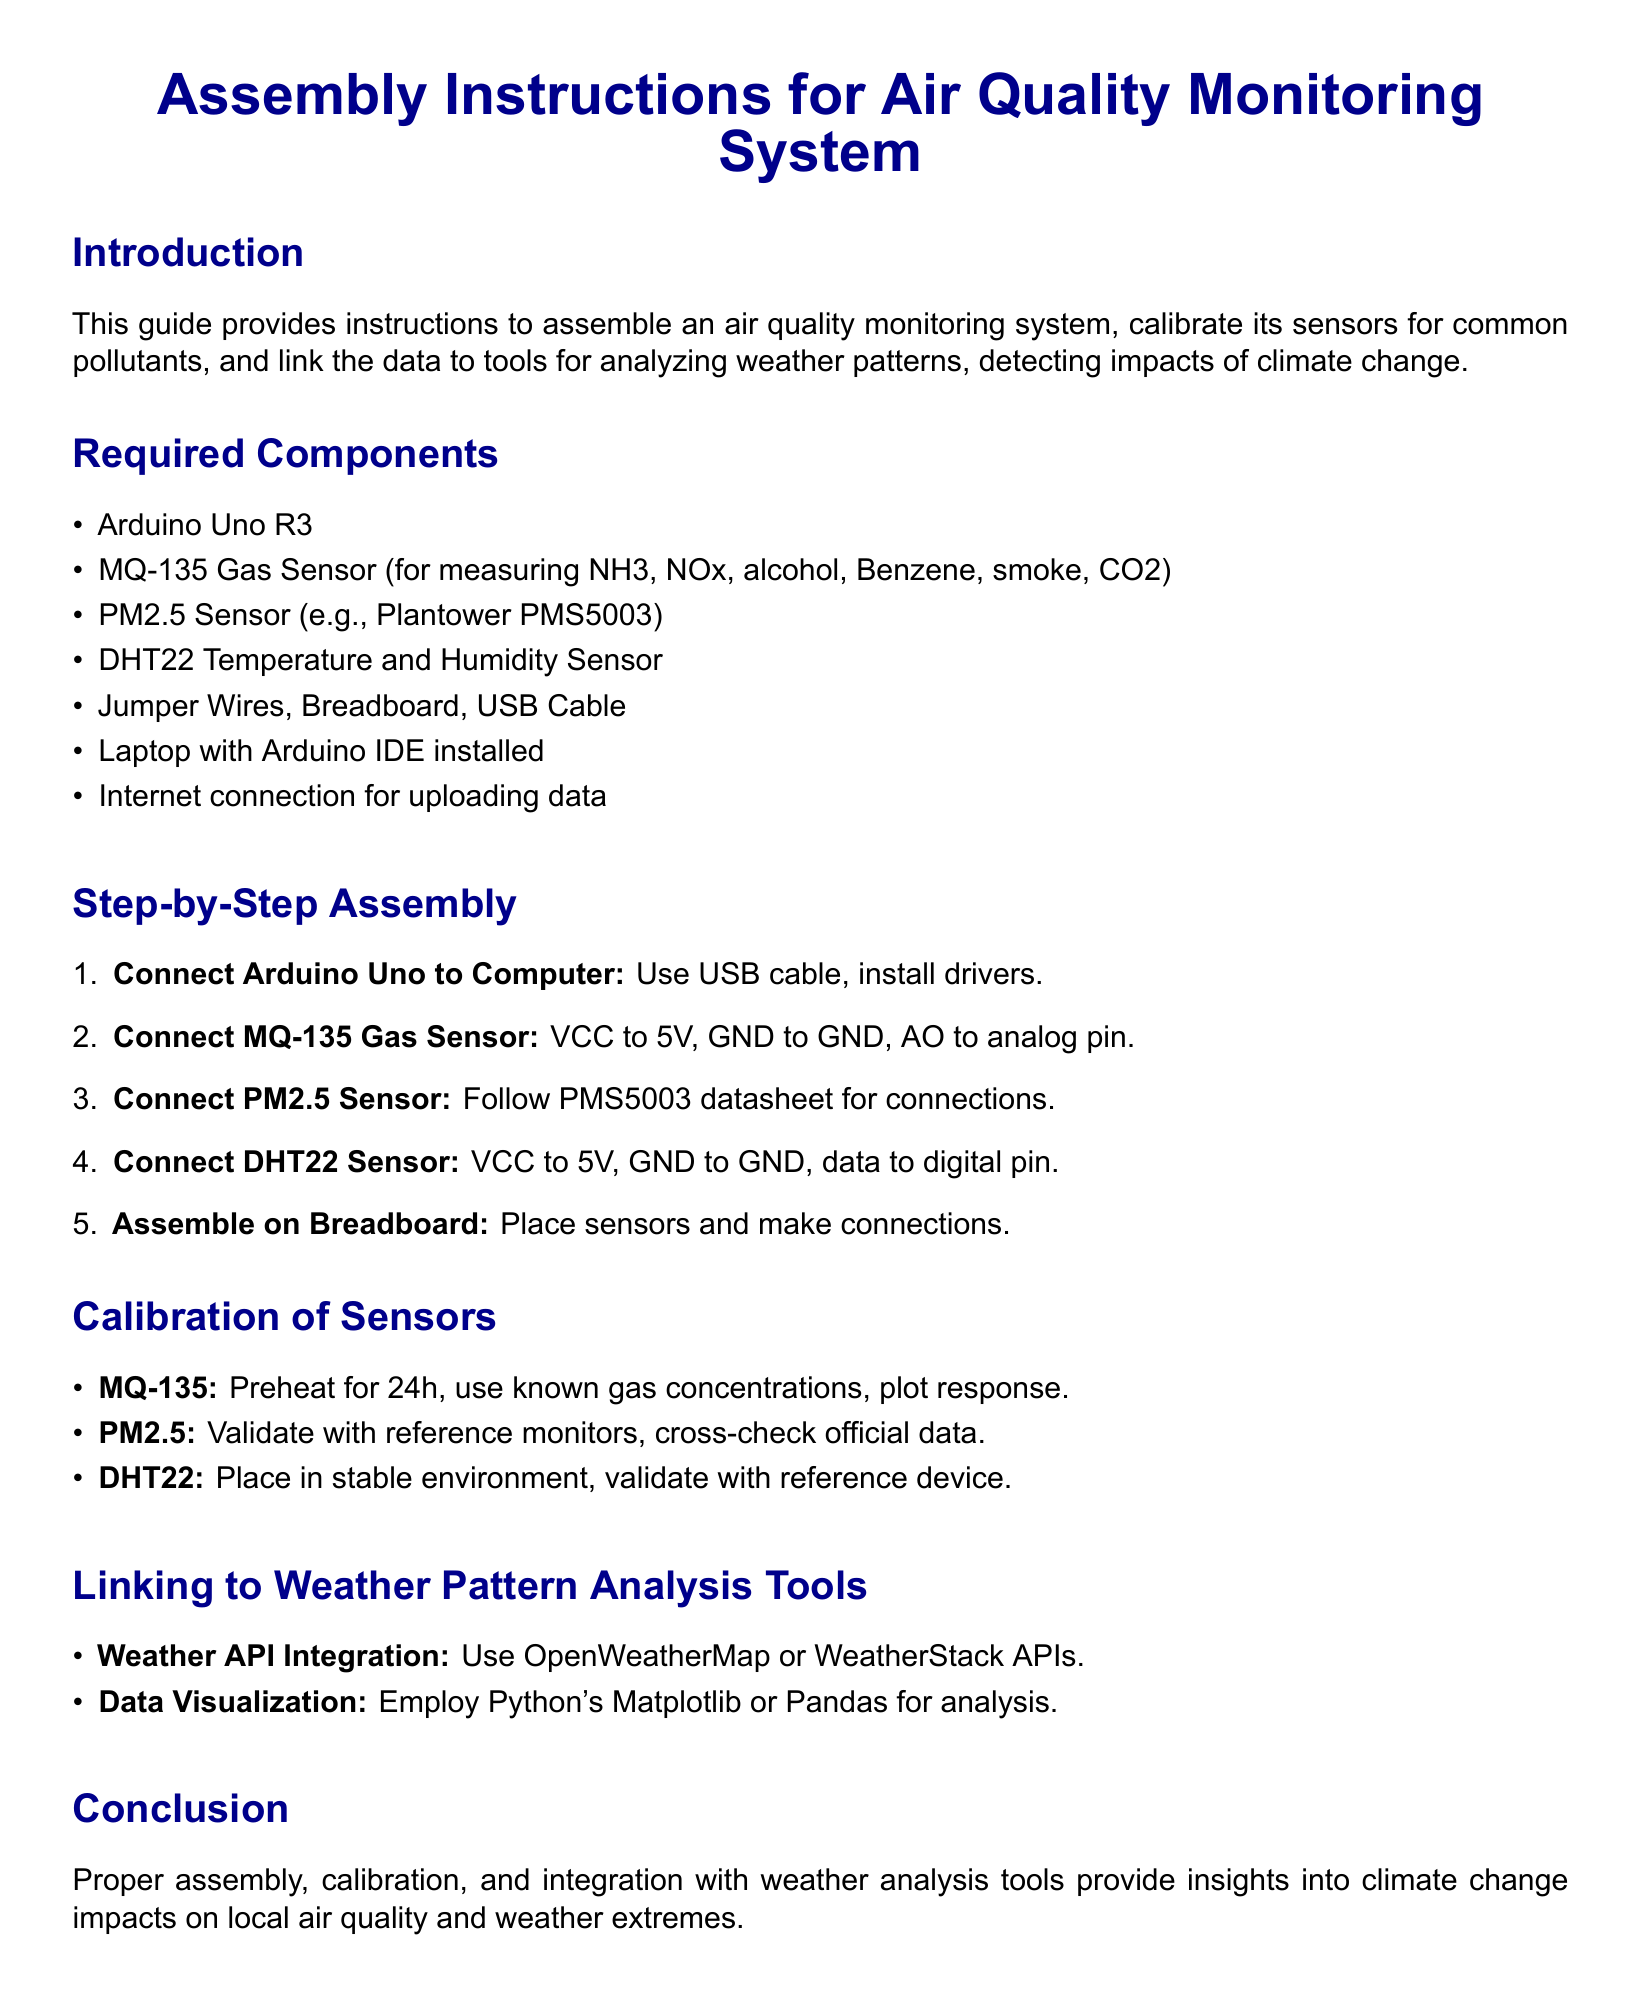What is the main purpose of the document? The document provides assembly instructions, calibration of sensors, and linkage to weather analysis tools for an air quality monitoring system.
Answer: Assembly instructions, calibration, linkage to weather analysis tools How many sensors are listed as required components? The document enumerates a list of required components, which includes three sensors.
Answer: Three sensors What type of sensor is the MQ-135? The MQ-135 sensor is specified for measuring several pollutants.
Answer: Gas sensor What is the first step in the assembly process? The first step involves connecting the Arduino Uno to the computer using a USB cable and installing drivers.
Answer: Connect Arduino Uno to Computer What is the purpose of calibrating the DHT22 sensor? The calibration of the DHT22 sensor should be done to validate it with a reference device.
Answer: To validate with a reference device Which data visualization tools are mentioned? The document mentions Python's Matplotlib or Pandas for data visualization.
Answer: Matplotlib or Pandas What is the preheating duration for the MQ-135 sensor? The document states that the MQ-135 sensor should be preheated for a specific duration before calibration.
Answer: 24h What APIs are suggested for weather data integration? The document suggests using OpenWeatherMap or WeatherStack APIs for weather data integration.
Answer: OpenWeatherMap or WeatherStack What is the installation requirement for the laptop? The laptop must have the Arduino IDE installed to work with the air quality monitoring system.
Answer: Arduino IDE installed 